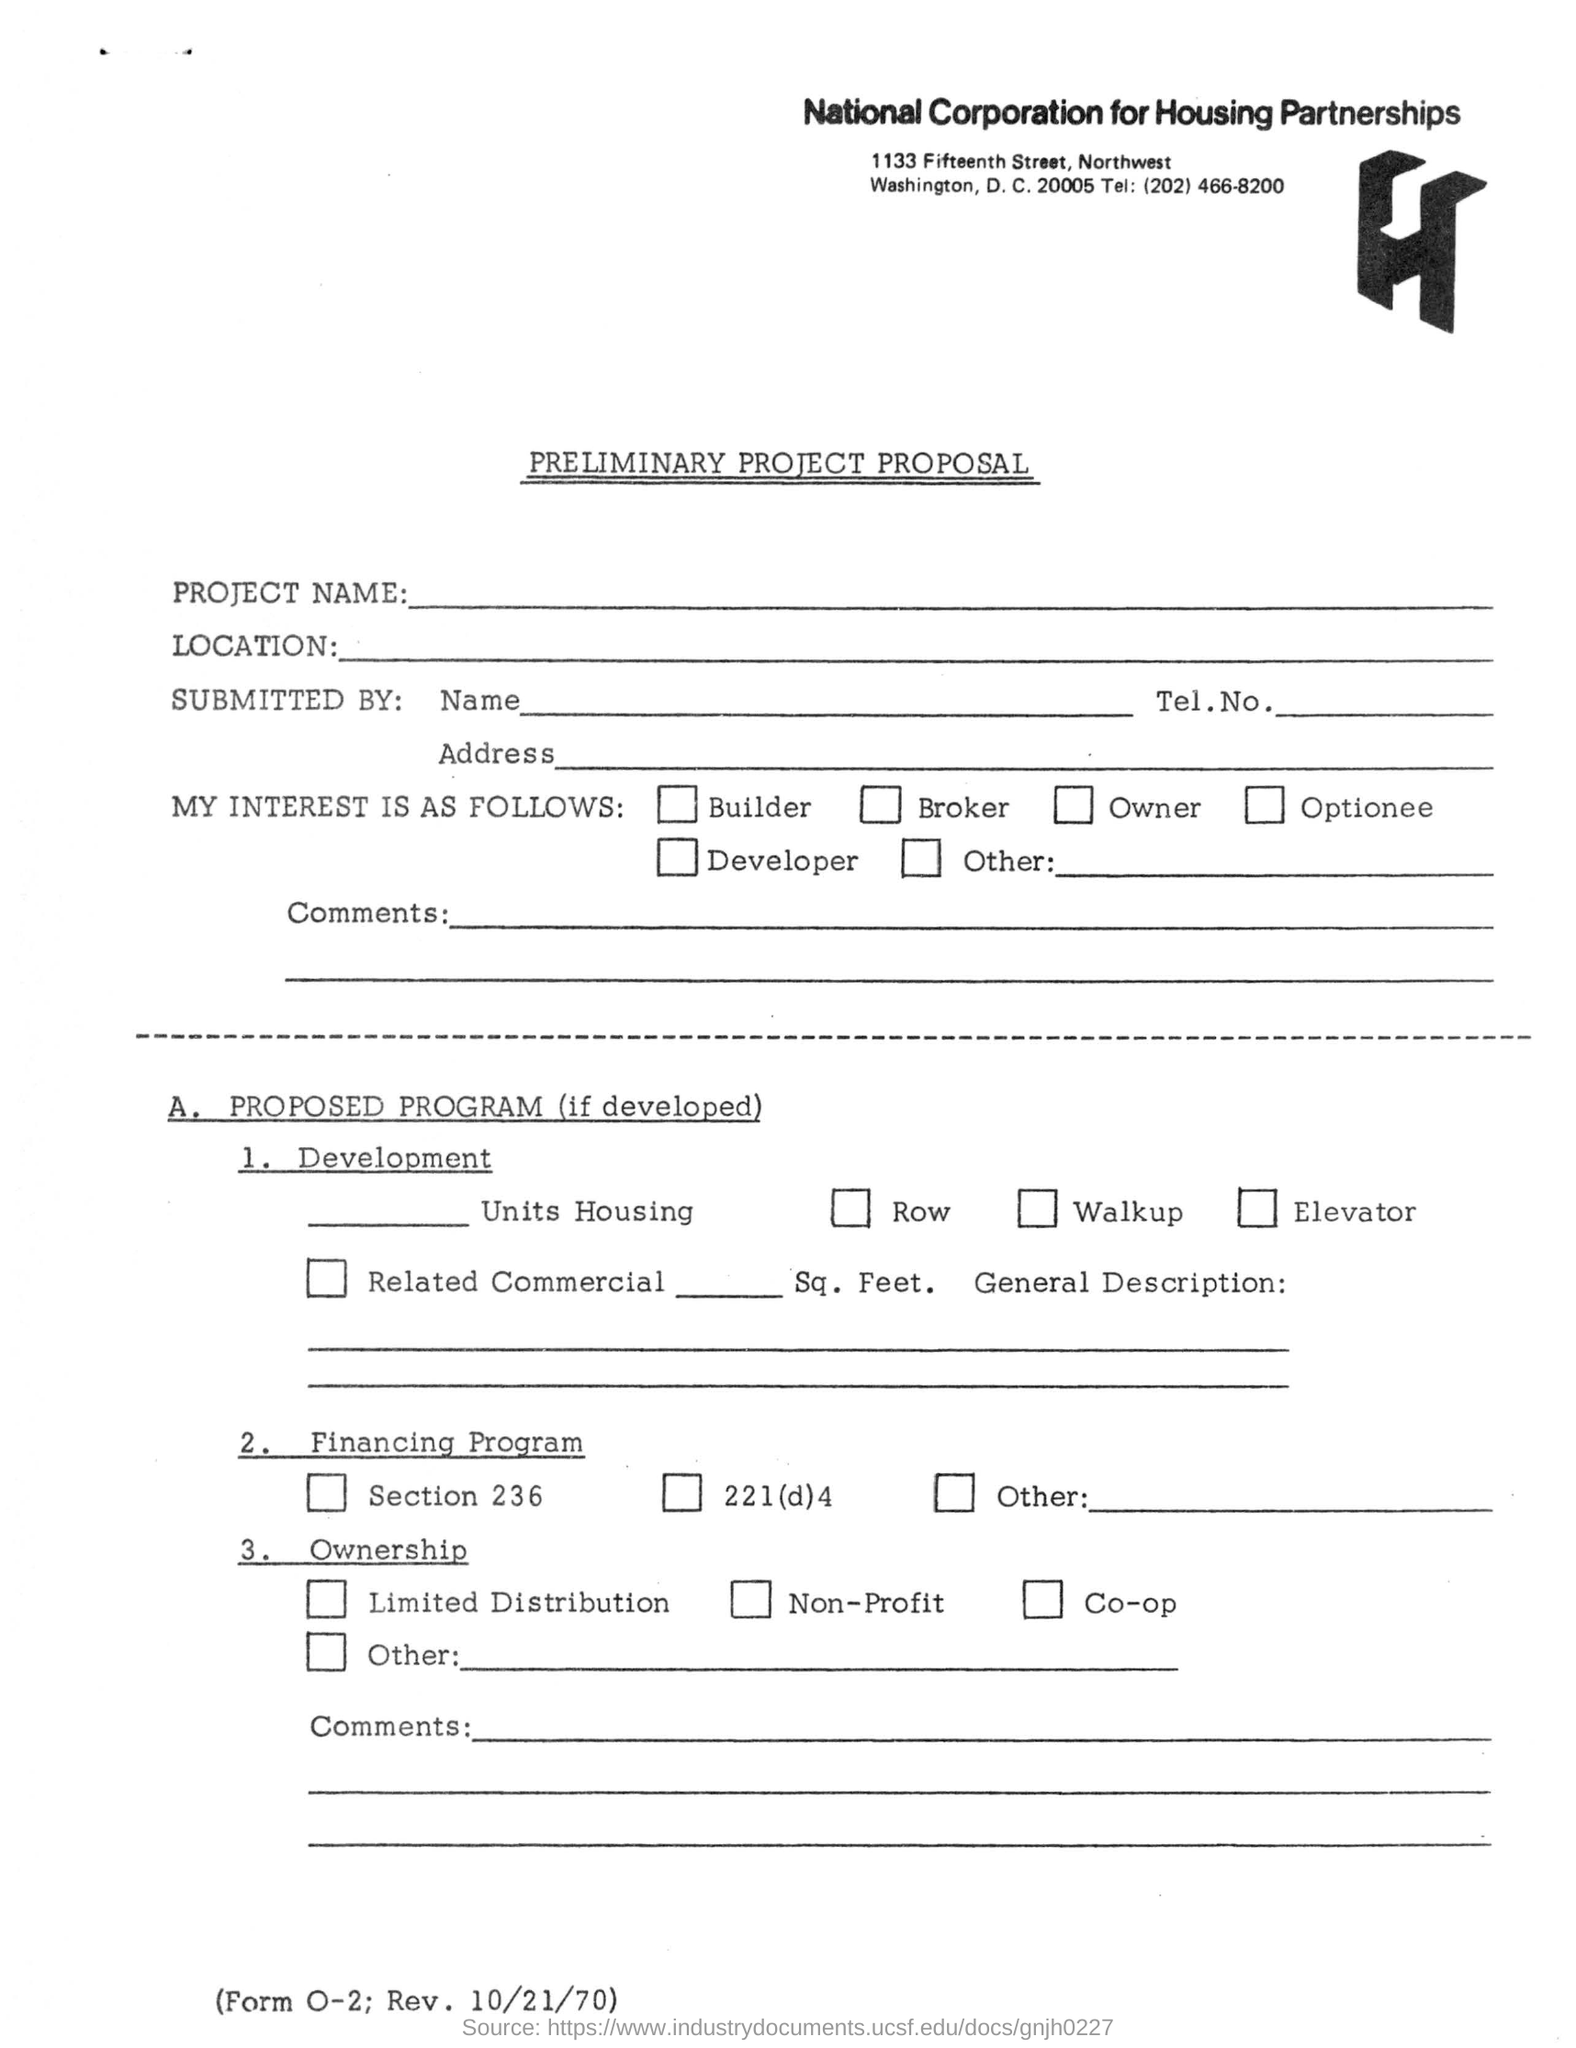Point out several critical features in this image. The telephone number provided in the form is (202) 466-8200. This document belongs to the National Corporation for Housing Partnerships. This is a preliminary project proposal in the form of... 